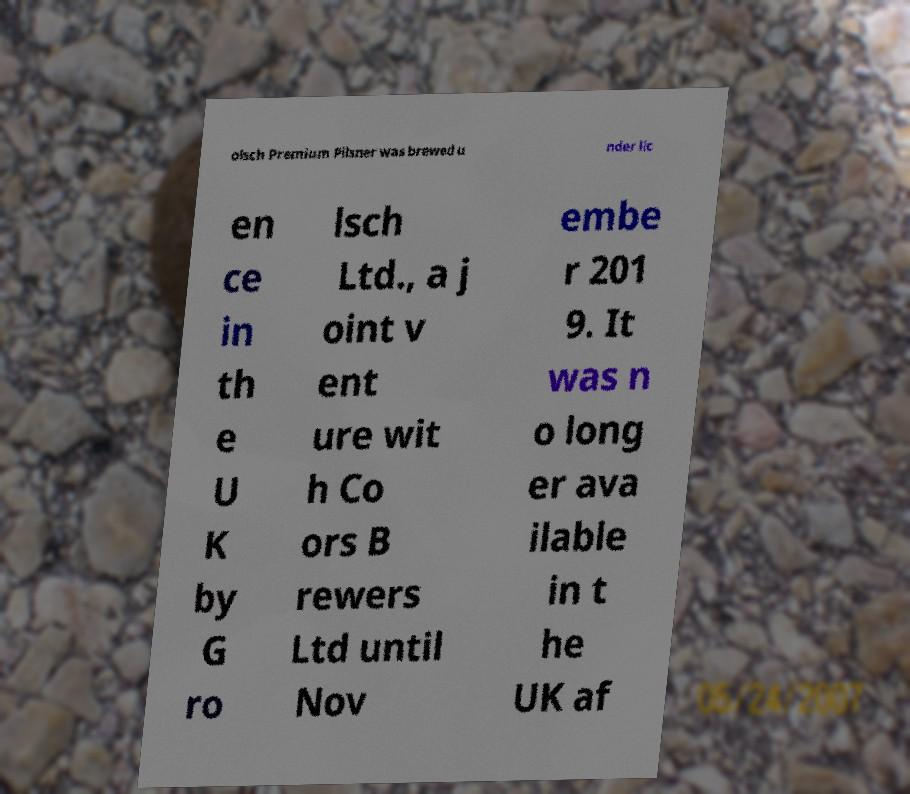Can you accurately transcribe the text from the provided image for me? olsch Premium Pilsner was brewed u nder lic en ce in th e U K by G ro lsch Ltd., a j oint v ent ure wit h Co ors B rewers Ltd until Nov embe r 201 9. It was n o long er ava ilable in t he UK af 